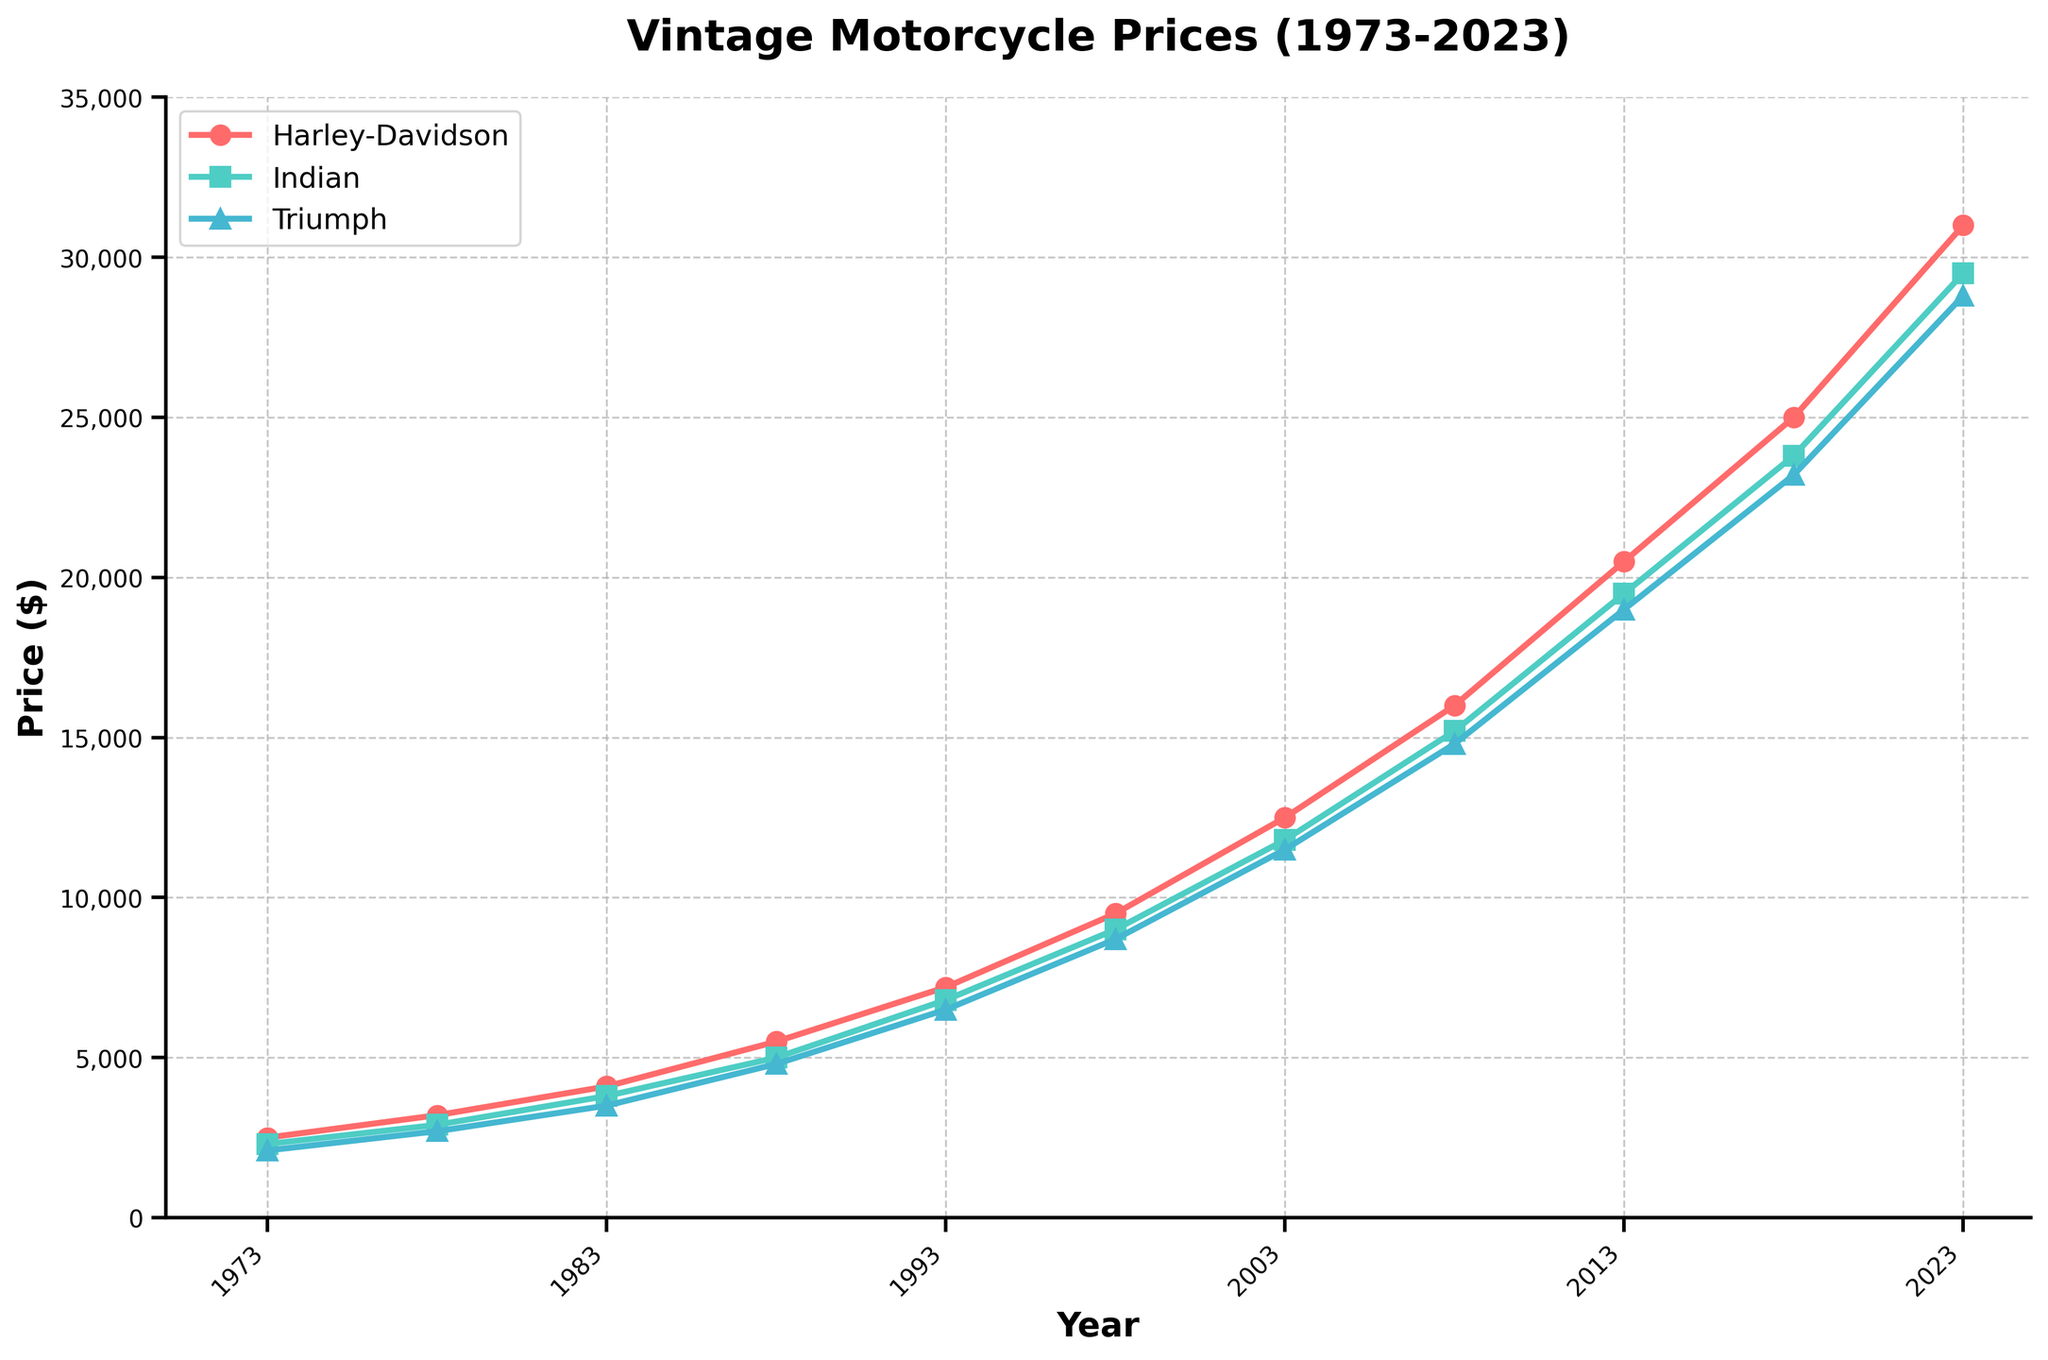What is the overall trend in the prices of Harley-Davidson motorcycles from 1973 to 2023? The overall trend shows that the prices of Harley-Davidson motorcycles have consistently increased from 1973 to 2023. The price started at $2500 in 1973 and reached $31000 in 2023, indicating a strong upward trend over the 50 years.
Answer: Upward trend Comparing the prices of Indian and Triumph motorcycles in 2023, which brand has the higher value? In 2023, Indian motorcycles are priced at $29500 while Triumph motorcycles are priced at $28800. Therefore, Indian motorcycles are priced higher than Triumph motorcycles in 2023.
Answer: Indian What was the price difference between Harley-Davidson and Indian motorcycles in 1988? In 1988, the price of Harley-Davidson motorcycles was $5500 and the price for Indian motorcycles was $5000. The difference between them is $5500 - $5000 = $500.
Answer: $500 How did the price of Triumph motorcycles change from 1978 to 1998? In 1978, the price of Triumph motorcycles was $2700. By 1998, the price increased to $8700. The change is $8700 - $2700 = $6000, indicating a significant increase over the 20 years.
Answer: Increased by $6000 Between which years did Indian motorcycles see the largest price increase? Indian motorcycles saw the largest price increase between 2018 and 2023. In 2018, the price was $23800, and it increased to $29500 in 2023, making the difference $29500 - $23800 = $5700.
Answer: 2018 to 2023 Which brand has the steepest price increase from 2003 to 2008? From 2003 to 2008, Harley-Davidson prices increased from $12500 to $16000, Indian prices from $11800 to $15200, and Triumph prices from $11500 to $14800. The price changes are $3500, $3400, and $3300, respectively. Thus, Harley-Davidson has the steepest price increase.
Answer: Harley-Davidson What was the average price of Harley-Davidson motorcycles during the first decade shown (1973-1983)? The prices of Harley-Davidson motorcycles during 1973-1983 are $2500, $3200, and $4100. The average is calculated as (2500 + 3200 + 4100) / 3 = $3266.67.
Answer: $3266.67 If you had bought one motorcycle from each brand in 1993, how much would the total cost be? The prices in 1993 are $7200 for Harley-Davidson, $6800 for Indian, and $6500 for Triumph. The total cost is $7200 + $6800 + $6500 = $20,500.
Answer: $20,500 By how much did the price of Triumph motorcycles increase from 1983 to 2003? The price of Triumph motorcycles in 1983 was $3500, and in 2003, it was $11500. The increase is $11500 - $3500 = $8000.
Answer: $8000 